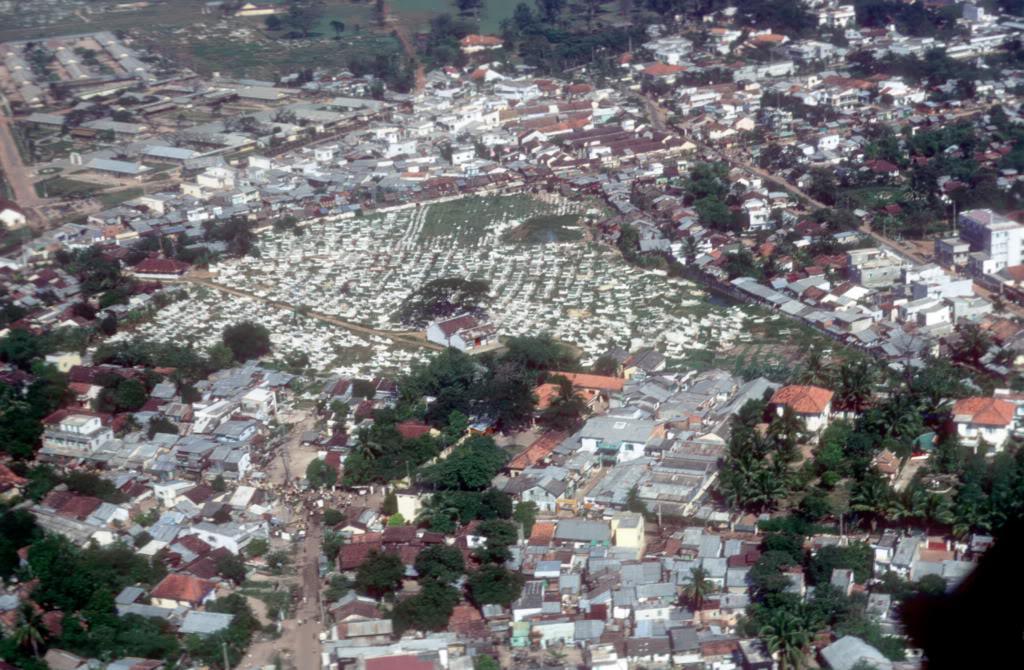Describe this image in one or two sentences. This is the aerial view image in which there are buildings, trees and there is grass. 